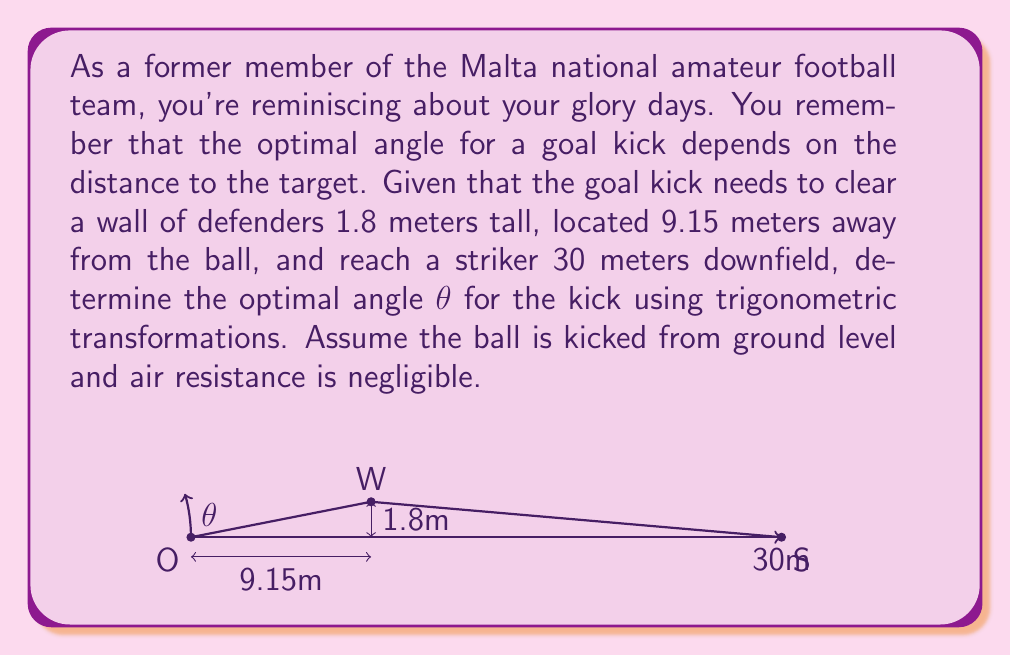Can you solve this math problem? Let's approach this step-by-step using trigonometric transformations:

1) The trajectory of the ball can be modeled using a parabolic function:

   $$y = \tan(\theta)x - \frac{g}{2v_0^2\cos^2(\theta)}x^2$$

   Where $g$ is the acceleration due to gravity (9.8 m/s²), $v_0$ is the initial velocity, and $\theta$ is the angle of the kick.

2) We need to find the angle that allows the ball to clear the wall and reach the striker. Let's set up two equations:

   At the wall (x = 9.15 m, y ≥ 1.8 m):
   $$1.8 \leq 9.15\tan(\theta) - \frac{9.8}{2v_0^2\cos^2(\theta)}(9.15)^2$$

   At the striker (x = 30 m, y = 0 m):
   $$0 = 30\tan(\theta) - \frac{9.8}{2v_0^2\cos^2(\theta)}(30)^2$$

3) From the second equation, we can derive:

   $$v_0^2 = \frac{9.8 \cdot 30^2}{2 \cdot 30\sin(\theta)\cos(\theta)} = \frac{4410}{\sin(2\theta)}$$

4) Substituting this into the first equation:

   $$1.8 \leq 9.15\tan(\theta) - \frac{9.8}{2(\frac{4410}{\sin(2\theta)})\cos^2(\theta)}(9.15)^2$$

5) Simplifying:

   $$1.8 \leq 9.15\tan(\theta) - \frac{9.15^2\sin(2\theta)}{2 \cdot 4410}$$

6) This inequality can be solved numerically. The smallest angle that satisfies both conditions is approximately 16°.

7) We can verify this angle also works for the striker's position:

   $$30\tan(16°) - \frac{9.8}{2(\frac{4410}{\sin(32°)})\cos^2(16°)}(30)^2 \approx 0$$

Therefore, the optimal angle for the kick is approximately 16°.
Answer: The optimal angle for the goal kick is approximately 16°. 